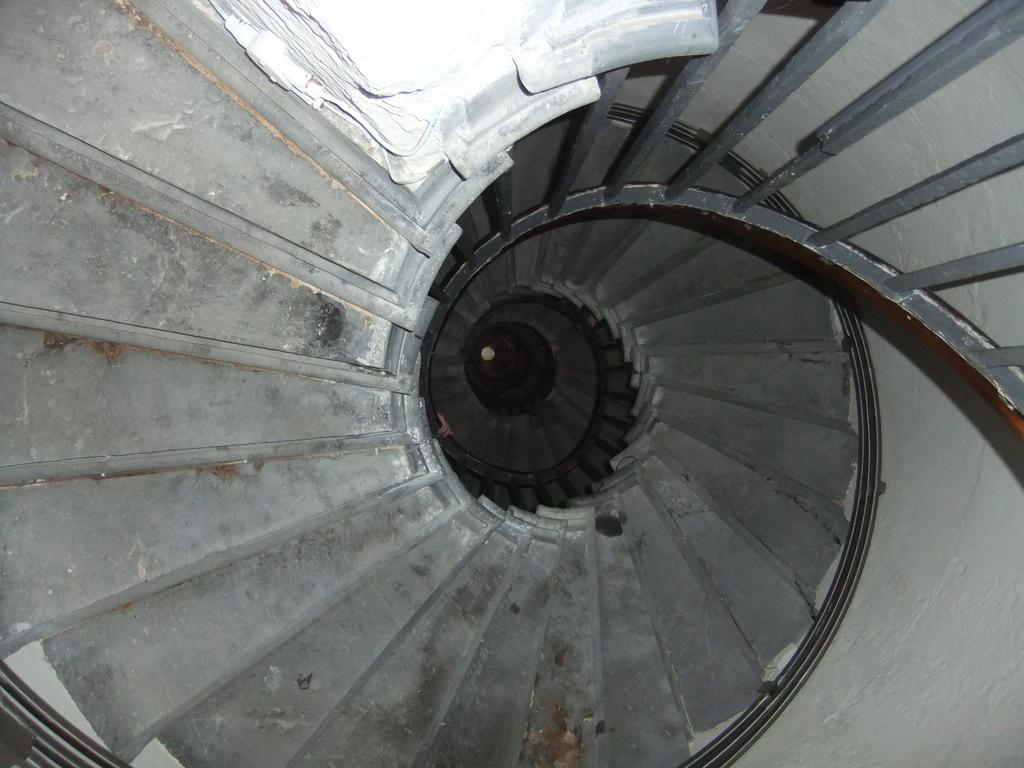What type of structure is present in the image? There are stairs in the image. What feature is associated with the stairs? There is railing in the image. What is the creator of the stairs doing in the image? There is no person or creator depicted in the image; it only shows the stairs and railing. What type of smell can be detected in the image? There is no information about smells in the image, as it only features stairs and railing. 